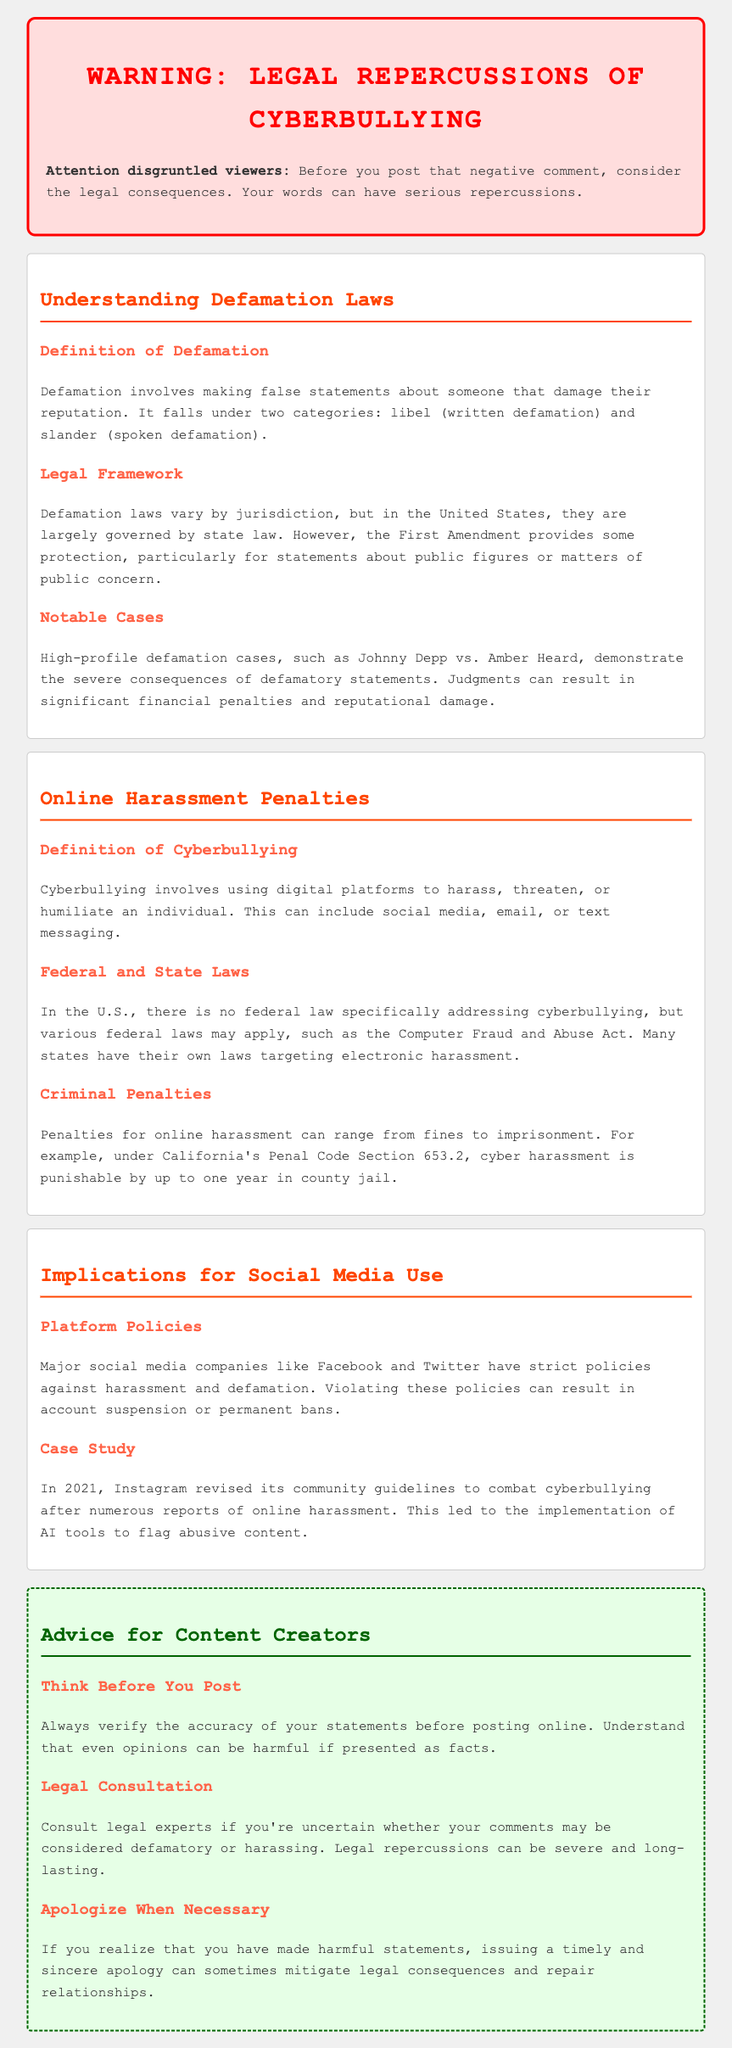What is the main warning to viewers? The document warns viewers about the legal consequences of posting negative comments.
Answer: Legal consequences What are the two categories of defamation? The document mentions that defamation falls under two categories: libel and slander.
Answer: Libel and slander Which famous case is highlighted as a notable example of defamation? The document references the case between Johnny Depp and Amber Heard as a notable example.
Answer: Johnny Depp vs. Amber Heard What can penalties for online harassment include? The document states that penalties for online harassment can range from fines to imprisonment.
Answer: Fines to imprisonment What does Section 653.2 of California's Penal Code pertain to? The document specifies that this section pertains to cyber harassment.
Answer: Cyber harassment What major social media platform is mentioned in relation to stricter harassment policies? The document discusses Instagram in context of revised community guidelines to combat cyberbullying.
Answer: Instagram What advice is given regarding posting online statements? The advice given in the document is to verify the accuracy of statements before posting.
Answer: Verify accuracy What should a person do if they realize they've made harmful statements? The document advises that issuing a timely and sincere apology can mitigate consequences.
Answer: Issue an apology 